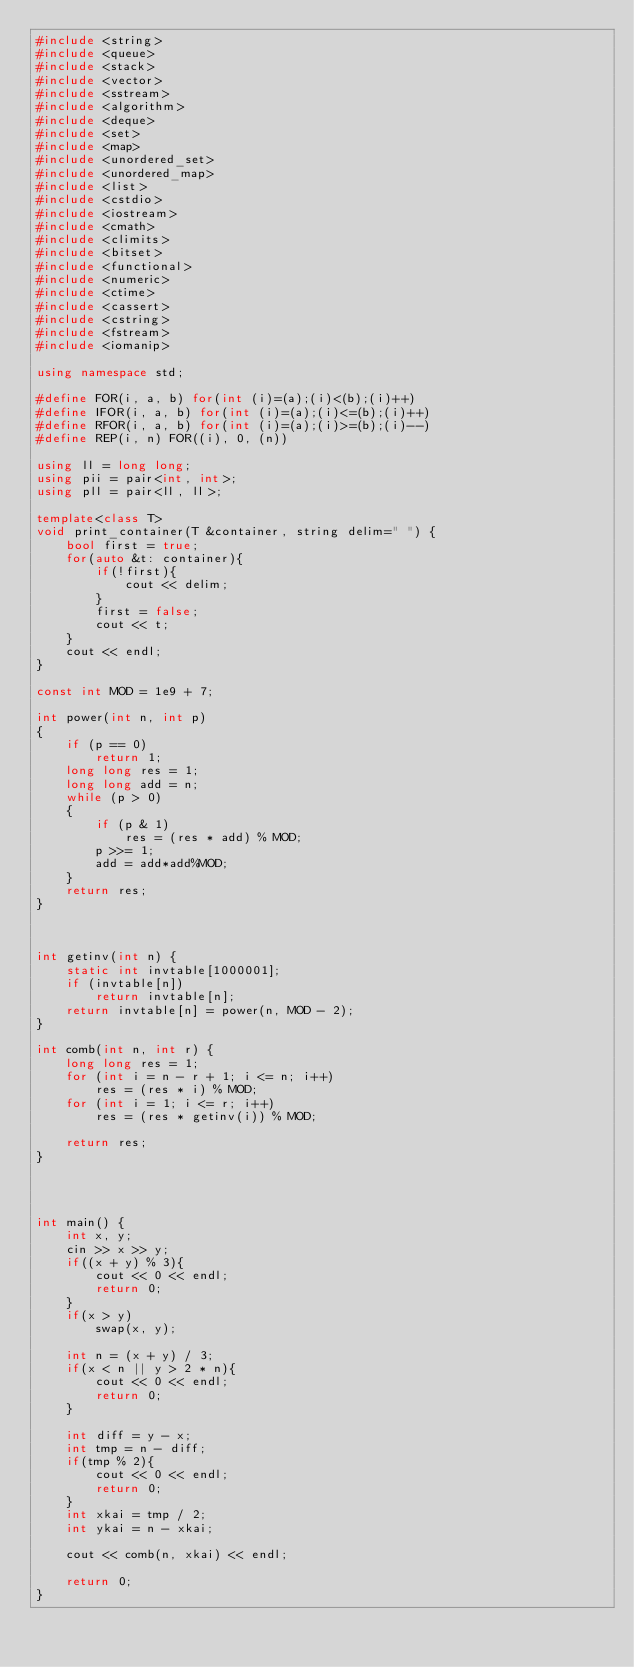Convert code to text. <code><loc_0><loc_0><loc_500><loc_500><_C++_>#include <string>
#include <queue>
#include <stack>
#include <vector>
#include <sstream>
#include <algorithm>
#include <deque>
#include <set>
#include <map>
#include <unordered_set>
#include <unordered_map>
#include <list>
#include <cstdio>
#include <iostream>
#include <cmath>
#include <climits>
#include <bitset>
#include <functional>
#include <numeric>
#include <ctime>
#include <cassert>
#include <cstring>
#include <fstream>
#include <iomanip>

using namespace std;

#define FOR(i, a, b) for(int (i)=(a);(i)<(b);(i)++)
#define IFOR(i, a, b) for(int (i)=(a);(i)<=(b);(i)++)
#define RFOR(i, a, b) for(int (i)=(a);(i)>=(b);(i)--)
#define REP(i, n) FOR((i), 0, (n))

using ll = long long;
using pii = pair<int, int>;
using pll = pair<ll, ll>;

template<class T>
void print_container(T &container, string delim=" ") {
    bool first = true;
    for(auto &t: container){
        if(!first){
            cout << delim;
        }
        first = false;
        cout << t;
    }
    cout << endl;
}

const int MOD = 1e9 + 7;

int power(int n, int p)
{
    if (p == 0)
        return 1;
    long long res = 1;
    long long add = n;
    while (p > 0)
    {
        if (p & 1)
            res = (res * add) % MOD;
        p >>= 1;
        add = add*add%MOD;
    }
    return res;
}

      

int getinv(int n) {
    static int invtable[1000001];
    if (invtable[n])
        return invtable[n];
    return invtable[n] = power(n, MOD - 2);
}

int comb(int n, int r) {
    long long res = 1;
    for (int i = n - r + 1; i <= n; i++)
        res = (res * i) % MOD;
    for (int i = 1; i <= r; i++)
        res = (res * getinv(i)) % MOD;

    return res;
}
      



int main() {
    int x, y;
    cin >> x >> y;
    if((x + y) % 3){
        cout << 0 << endl;
        return 0;
    }
    if(x > y)
        swap(x, y);
    
    int n = (x + y) / 3;
    if(x < n || y > 2 * n){
        cout << 0 << endl;
        return 0;
    }

    int diff = y - x;
    int tmp = n - diff;
    if(tmp % 2){
        cout << 0 << endl;
        return 0;
    }
    int xkai = tmp / 2;
    int ykai = n - xkai;

    cout << comb(n, xkai) << endl;

    return 0;
}</code> 